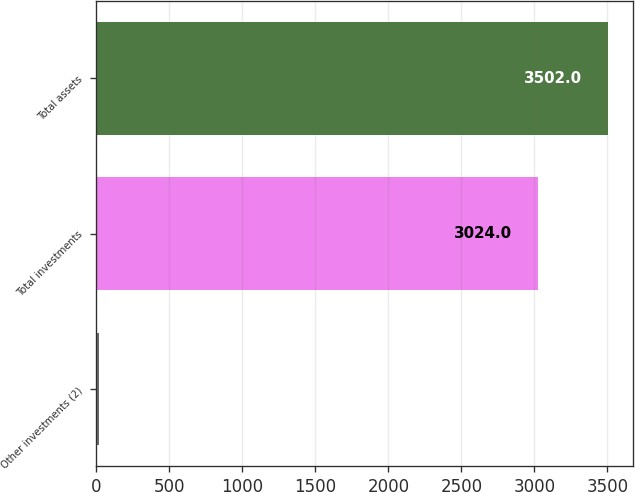Convert chart to OTSL. <chart><loc_0><loc_0><loc_500><loc_500><bar_chart><fcel>Other investments (2)<fcel>Total investments<fcel>Total assets<nl><fcel>18<fcel>3024<fcel>3502<nl></chart> 